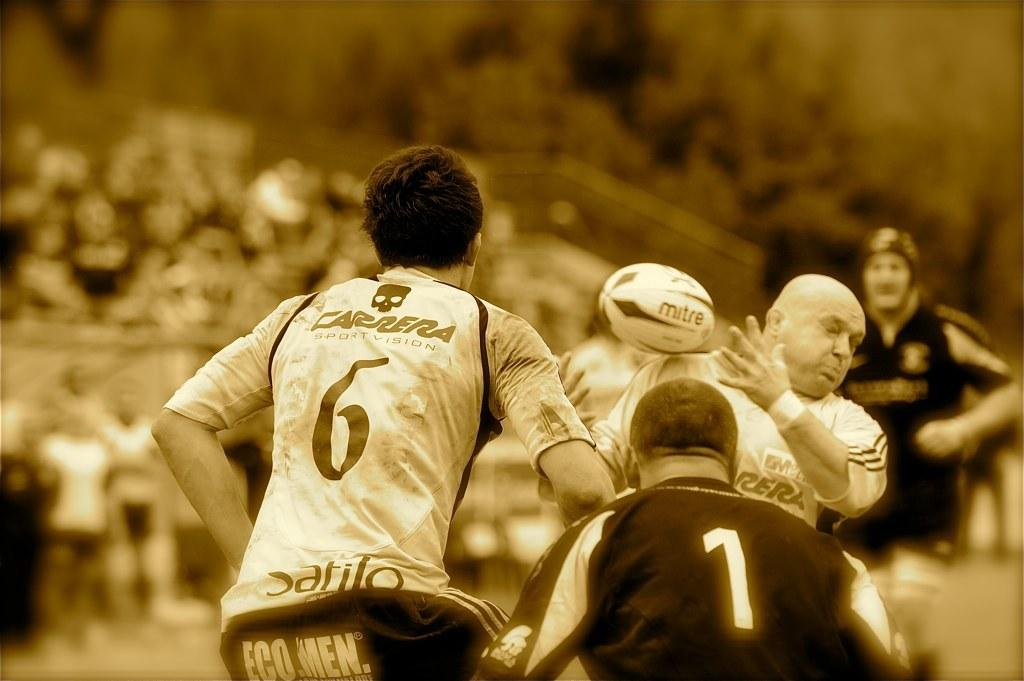<image>
Provide a brief description of the given image. a sepia picture of rugby, with one man wearing a number 6 shirt and one a number 1 